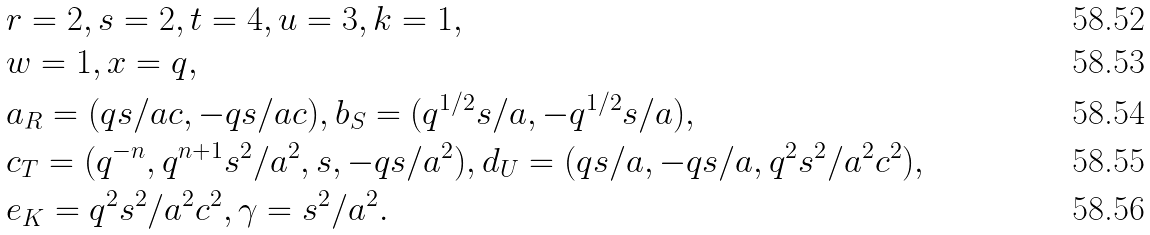Convert formula to latex. <formula><loc_0><loc_0><loc_500><loc_500>& r = 2 , s = 2 , t = 4 , u = 3 , k = 1 , \\ & w = 1 , x = q , \\ & a _ { R } = ( q s / a c , - q s / a c ) , b _ { S } = ( q ^ { 1 / 2 } s / a , - q ^ { 1 / 2 } s / a ) , \\ & c _ { T } = ( q ^ { - n } , q ^ { n + 1 } s ^ { 2 } / a ^ { 2 } , s , - q s / a ^ { 2 } ) , d _ { U } = ( q s / a , - q s / a , q ^ { 2 } s ^ { 2 } / a ^ { 2 } c ^ { 2 } ) , \\ & e _ { K } = q ^ { 2 } s ^ { 2 } / a ^ { 2 } c ^ { 2 } , \gamma = s ^ { 2 } / a ^ { 2 } .</formula> 